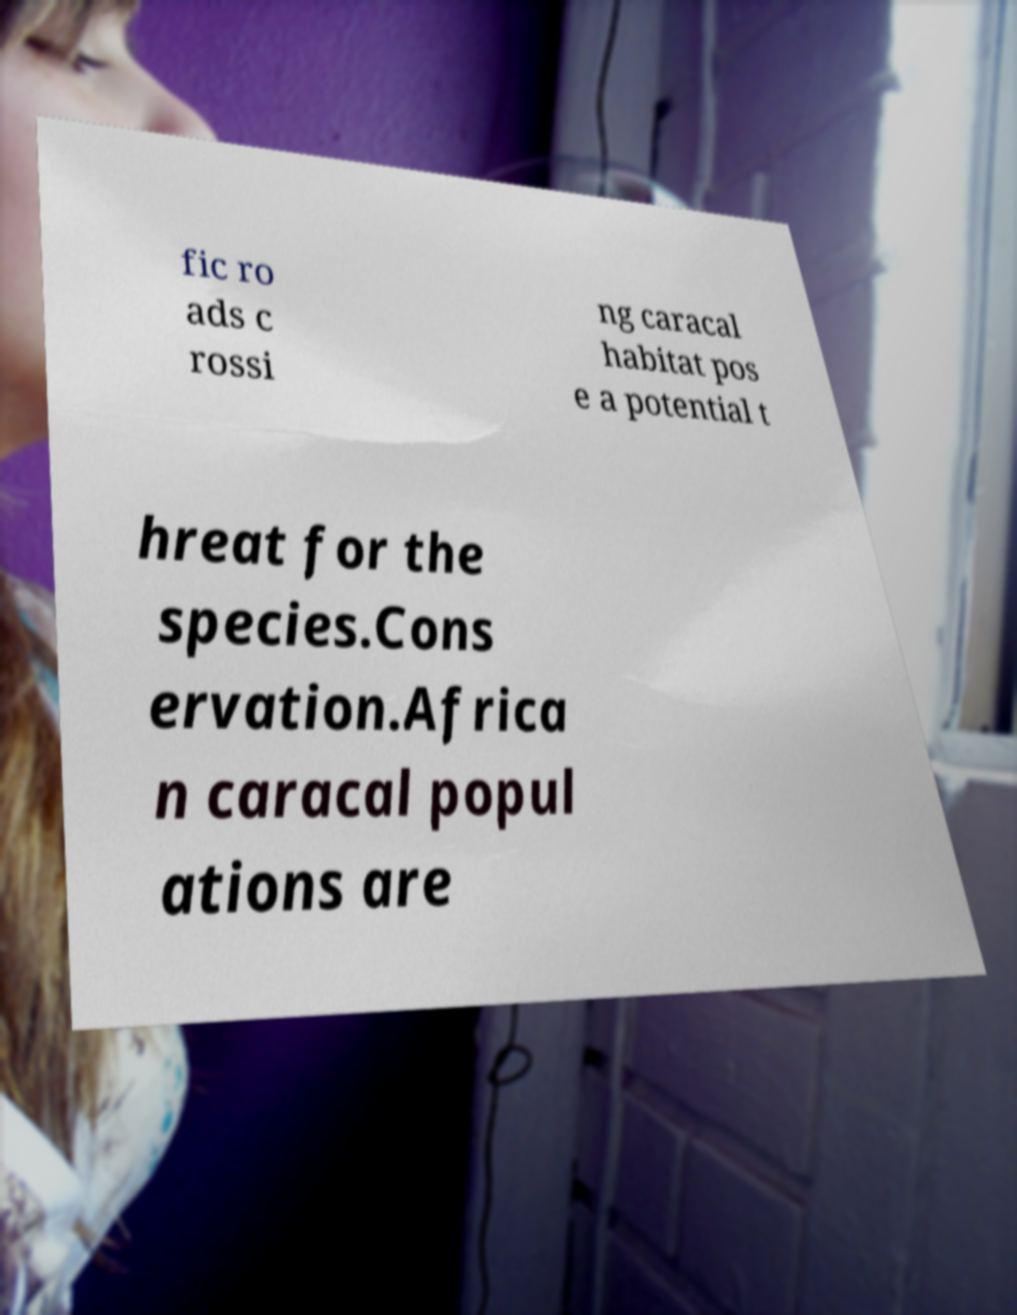I need the written content from this picture converted into text. Can you do that? fic ro ads c rossi ng caracal habitat pos e a potential t hreat for the species.Cons ervation.Africa n caracal popul ations are 